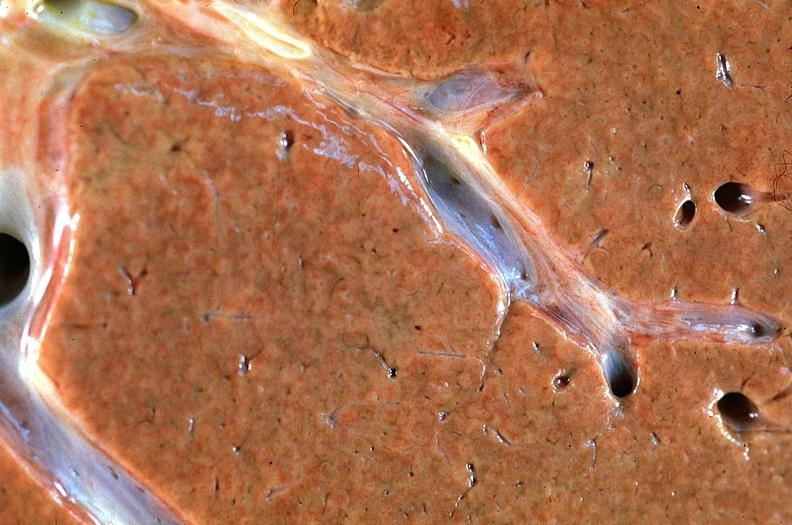s candida present?
Answer the question using a single word or phrase. No 